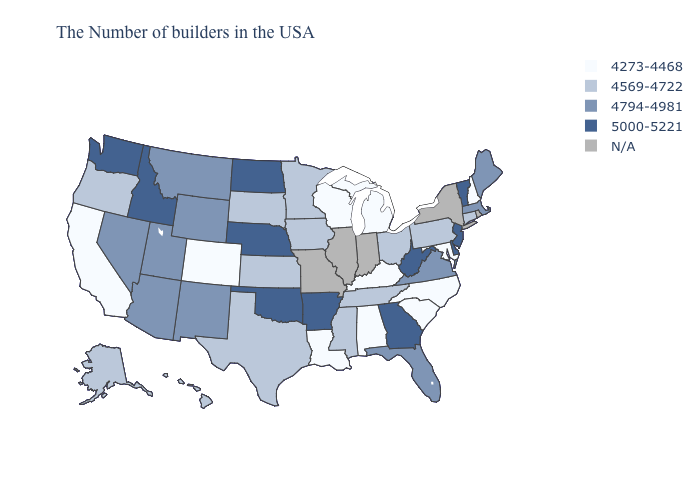What is the value of Vermont?
Short answer required. 5000-5221. What is the value of Louisiana?
Answer briefly. 4273-4468. Name the states that have a value in the range 4794-4981?
Give a very brief answer. Maine, Massachusetts, Virginia, Florida, Wyoming, New Mexico, Utah, Montana, Arizona, Nevada. What is the value of Louisiana?
Give a very brief answer. 4273-4468. Does the first symbol in the legend represent the smallest category?
Quick response, please. Yes. Name the states that have a value in the range 4569-4722?
Write a very short answer. Connecticut, Pennsylvania, Ohio, Tennessee, Mississippi, Minnesota, Iowa, Kansas, Texas, South Dakota, Oregon, Alaska, Hawaii. Among the states that border Missouri , which have the lowest value?
Write a very short answer. Kentucky. What is the value of Alabama?
Keep it brief. 4273-4468. What is the highest value in the USA?
Be succinct. 5000-5221. Name the states that have a value in the range 5000-5221?
Write a very short answer. Vermont, New Jersey, Delaware, West Virginia, Georgia, Arkansas, Nebraska, Oklahoma, North Dakota, Idaho, Washington. Does the map have missing data?
Write a very short answer. Yes. What is the value of Louisiana?
Be succinct. 4273-4468. What is the value of Alabama?
Keep it brief. 4273-4468. Among the states that border Oklahoma , which have the highest value?
Short answer required. Arkansas. Does North Carolina have the lowest value in the USA?
Write a very short answer. Yes. 